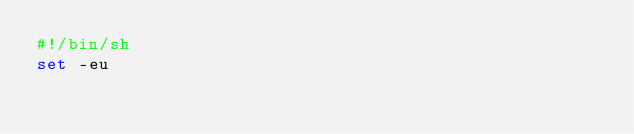<code> <loc_0><loc_0><loc_500><loc_500><_Bash_>#!/bin/sh
set -eu
</code> 